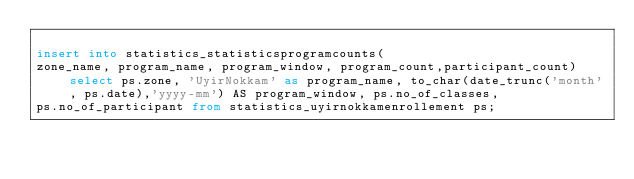Convert code to text. <code><loc_0><loc_0><loc_500><loc_500><_SQL_>
insert into statistics_statisticsprogramcounts(
zone_name, program_name, program_window, program_count,participant_count) select ps.zone, 'UyirNokkam' as program_name, to_char(date_trunc('month', ps.date),'yyyy-mm') AS program_window, ps.no_of_classes,
ps.no_of_participant from statistics_uyirnokkamenrollement ps;</code> 